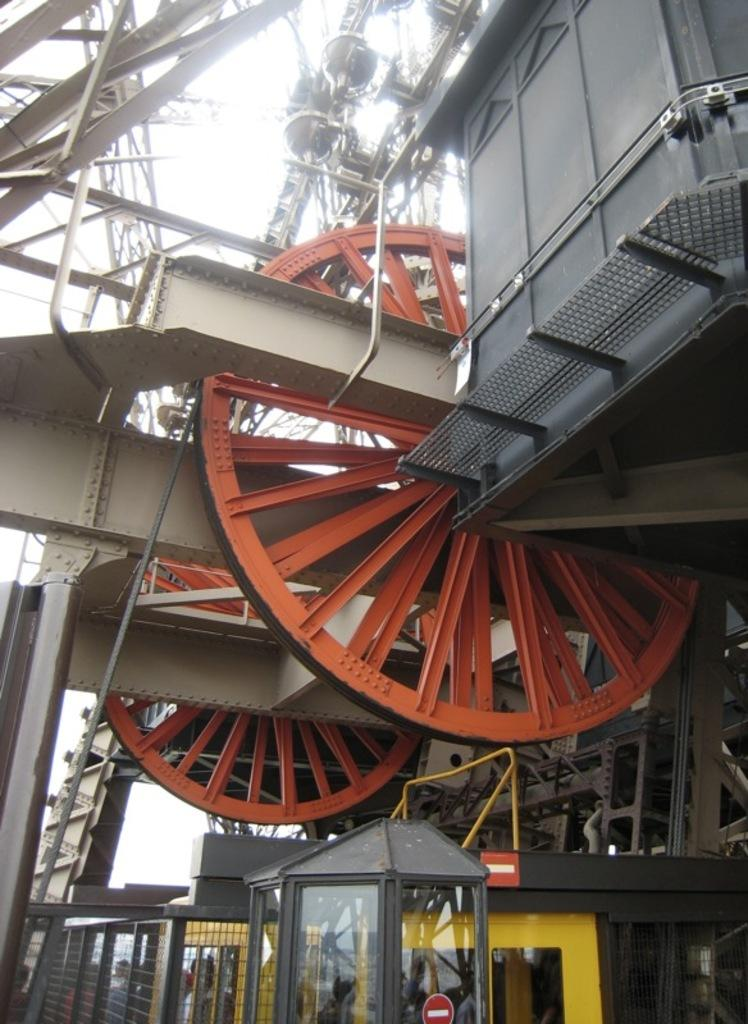What type of objects can be seen in the image? There are machines and stands in the image. What is the weather like in the image? The sky is cloudy in the image. Are there any people present in the image? Yes, there are persons in the image. What might be used for cooking in the image? There is a grill in the image. What type of zinc is being used to create the machines in the image? There is no mention of zinc being used in the creation of the machines in the image. Can you tell me the name of the secretary working at the stands in the image? There is no secretary present in the image; only persons are mentioned. 